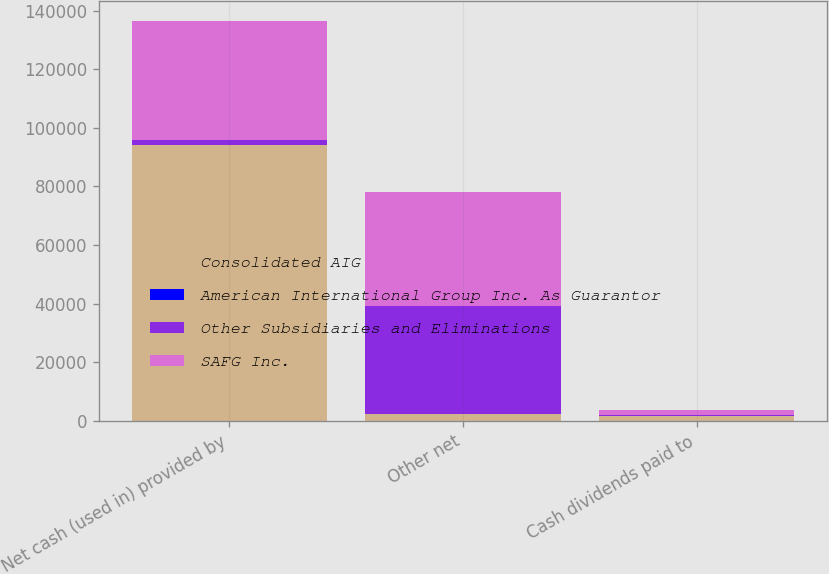Convert chart to OTSL. <chart><loc_0><loc_0><loc_500><loc_500><stacked_bar_chart><ecel><fcel>Net cash (used in) provided by<fcel>Other net<fcel>Cash dividends paid to<nl><fcel>Consolidated AIG<fcel>94073<fcel>2356<fcel>1628<nl><fcel>American International Group Inc. As Guarantor<fcel>43<fcel>16<fcel>180<nl><fcel>Other Subsidiaries and Eliminations<fcel>1628<fcel>36770<fcel>180<nl><fcel>SAFG Inc.<fcel>40734<fcel>39110<fcel>1628<nl></chart> 